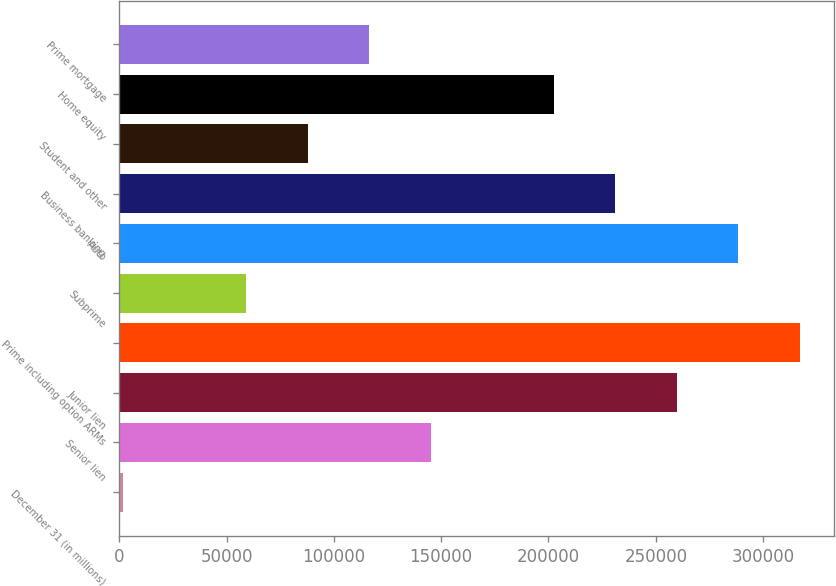Convert chart to OTSL. <chart><loc_0><loc_0><loc_500><loc_500><bar_chart><fcel>December 31 (in millions)<fcel>Senior lien<fcel>Junior lien<fcel>Prime including option ARMs<fcel>Subprime<fcel>Auto<fcel>Business banking<fcel>Student and other<fcel>Home equity<fcel>Prime mortgage<nl><fcel>2013<fcel>145231<fcel>259805<fcel>317093<fcel>59300.2<fcel>288449<fcel>231162<fcel>87943.8<fcel>202518<fcel>116587<nl></chart> 